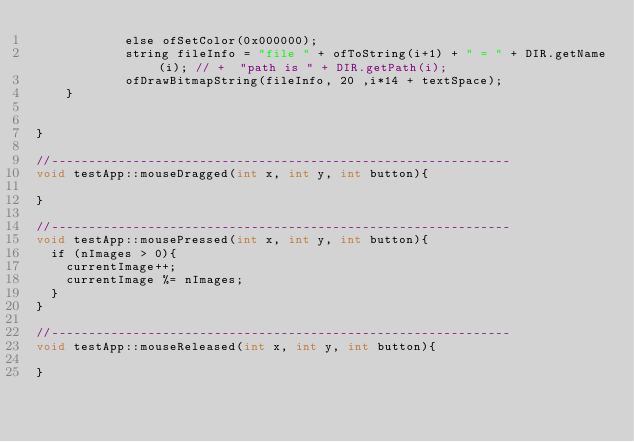<code> <loc_0><loc_0><loc_500><loc_500><_ObjectiveC_>            else ofSetColor(0x000000);
            string fileInfo = "file " + ofToString(i+1) + " = " + DIR.getName(i); // +  "path is " + DIR.getPath(i);
            ofDrawBitmapString(fileInfo, 20 ,i*14 + textSpace);
    }

	
}

//--------------------------------------------------------------
void testApp::mouseDragged(int x, int y, int button){
	
}

//--------------------------------------------------------------
void testApp::mousePressed(int x, int y, int button){
	if (nImages > 0){
		currentImage++;
		currentImage %= nImages;
	}
}

//--------------------------------------------------------------
void testApp::mouseReleased(int x, int y, int button){

}
</code> 